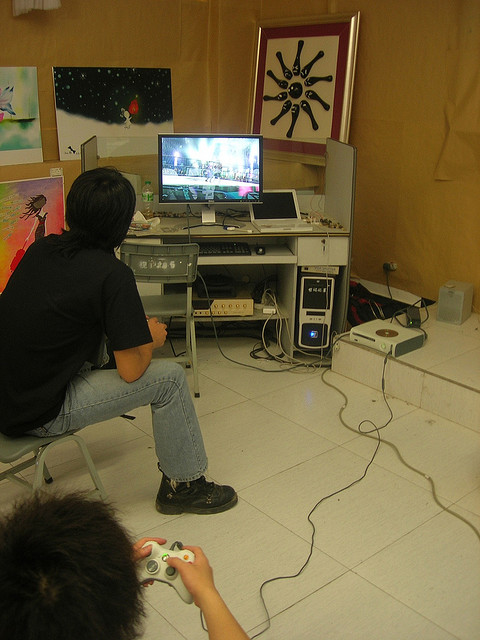<image>What type of game system is the boy playing? It is unknown what type of game system the boy is playing. It could be a Playstation, Xbox, computer, or Sega. What type of game system is the boy playing? I don't know what type of game system the boy is playing. It can be either a Playstation, Xbox, Xbox 360, Playstation 64, or Sega. 